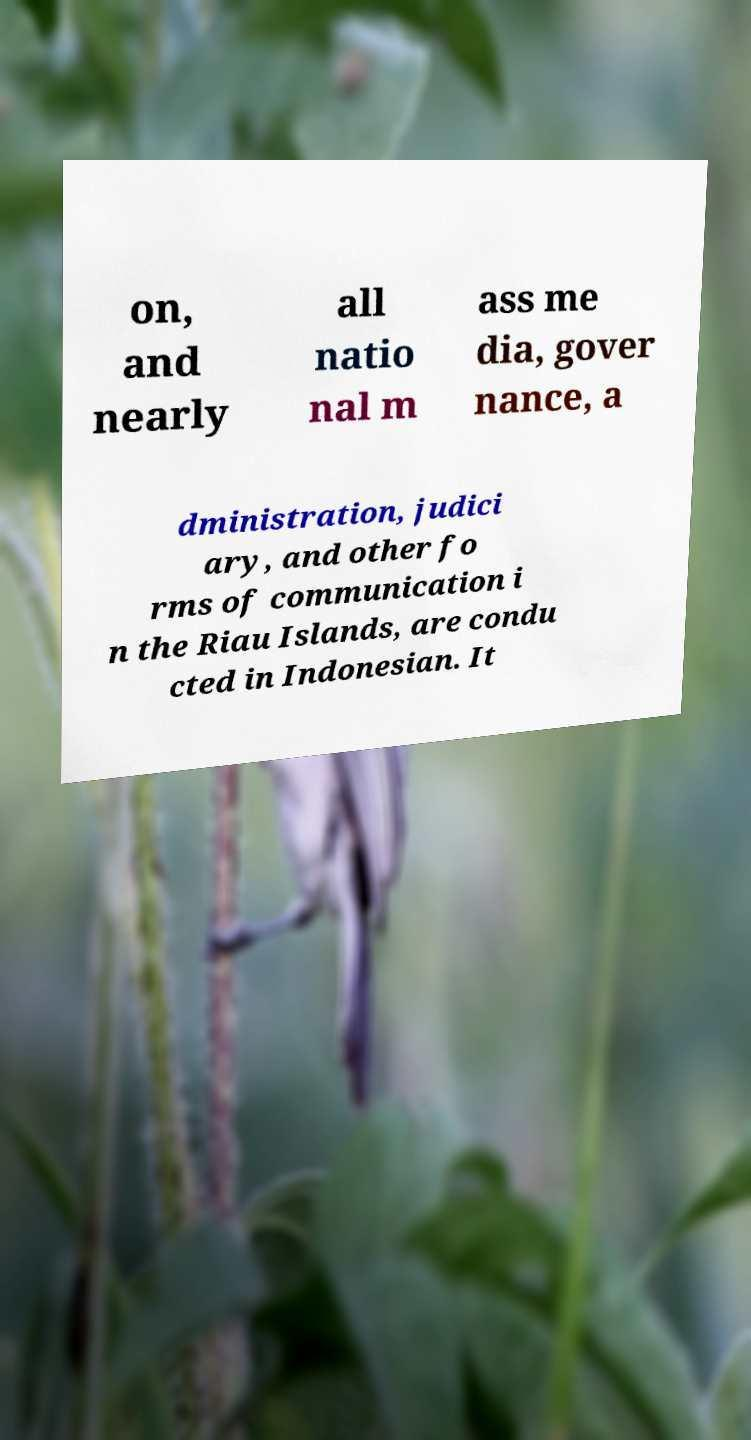For documentation purposes, I need the text within this image transcribed. Could you provide that? on, and nearly all natio nal m ass me dia, gover nance, a dministration, judici ary, and other fo rms of communication i n the Riau Islands, are condu cted in Indonesian. It 